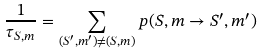Convert formula to latex. <formula><loc_0><loc_0><loc_500><loc_500>\frac { 1 } { \tau _ { S , m } } = \sum _ { ( S ^ { \prime } , m ^ { \prime } ) \ne ( S , m ) } p ( S , m \rightarrow S ^ { \prime } , m ^ { \prime } )</formula> 